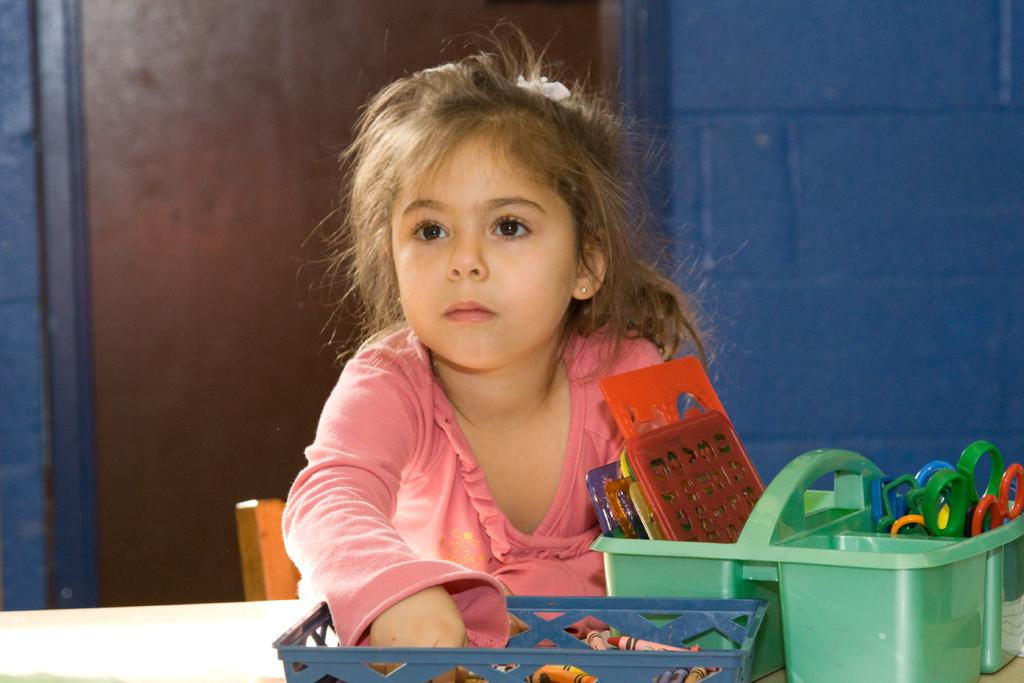What is the person in the image wearing? The person in the image is wearing a peach-colored dress. What can be seen in the image besides the person? There are colorful objects in the image. What colors are present in the background of the image? The background of the image is blue and brown. What type of wound can be seen on the person's arm in the image? There is no wound visible on the person's arm in the image. What is the coil used for in the image? There is no coil present in the image. 